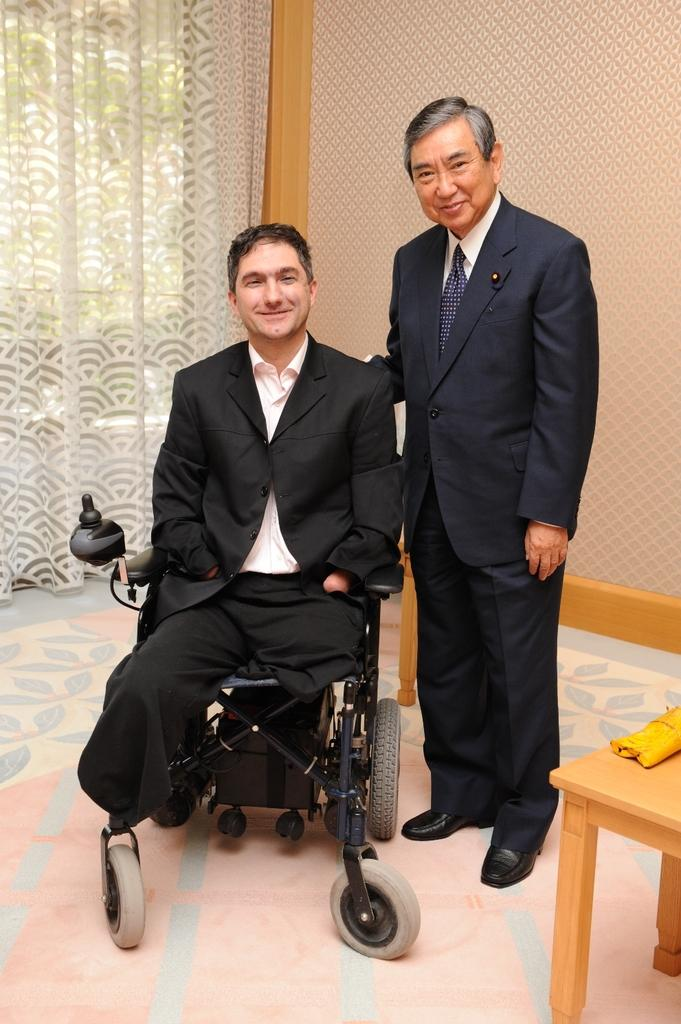What is the main subject of the image? The main subject of the image is a person in a wheelchair. Can you describe the person in the wheelchair? The person in the wheelchair is disabled. Who is present with the person in the wheelchair? There is another person standing beside the person in the wheelchair. What can be seen in the background of the image? There is a white curtain in the background of the image. What is the income of the person in the wheelchair in the image? There is no information about the person's income in the image. How does the summer season affect the person in the wheelchair in the image? The image does not provide any information about the season or how it might affect the person in the wheelchair. 